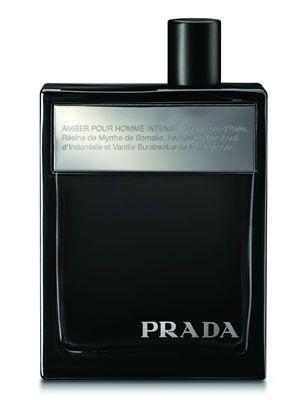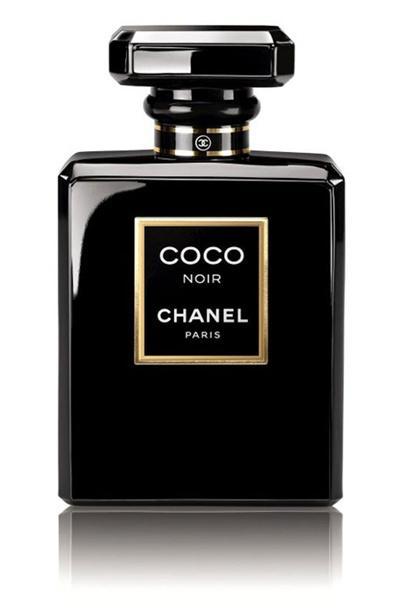The first image is the image on the left, the second image is the image on the right. For the images shown, is this caption "One square shaped bottle of men's cologne is shown in each of two images, one with a round cap and the other with a square cap." true? Answer yes or no. No. 